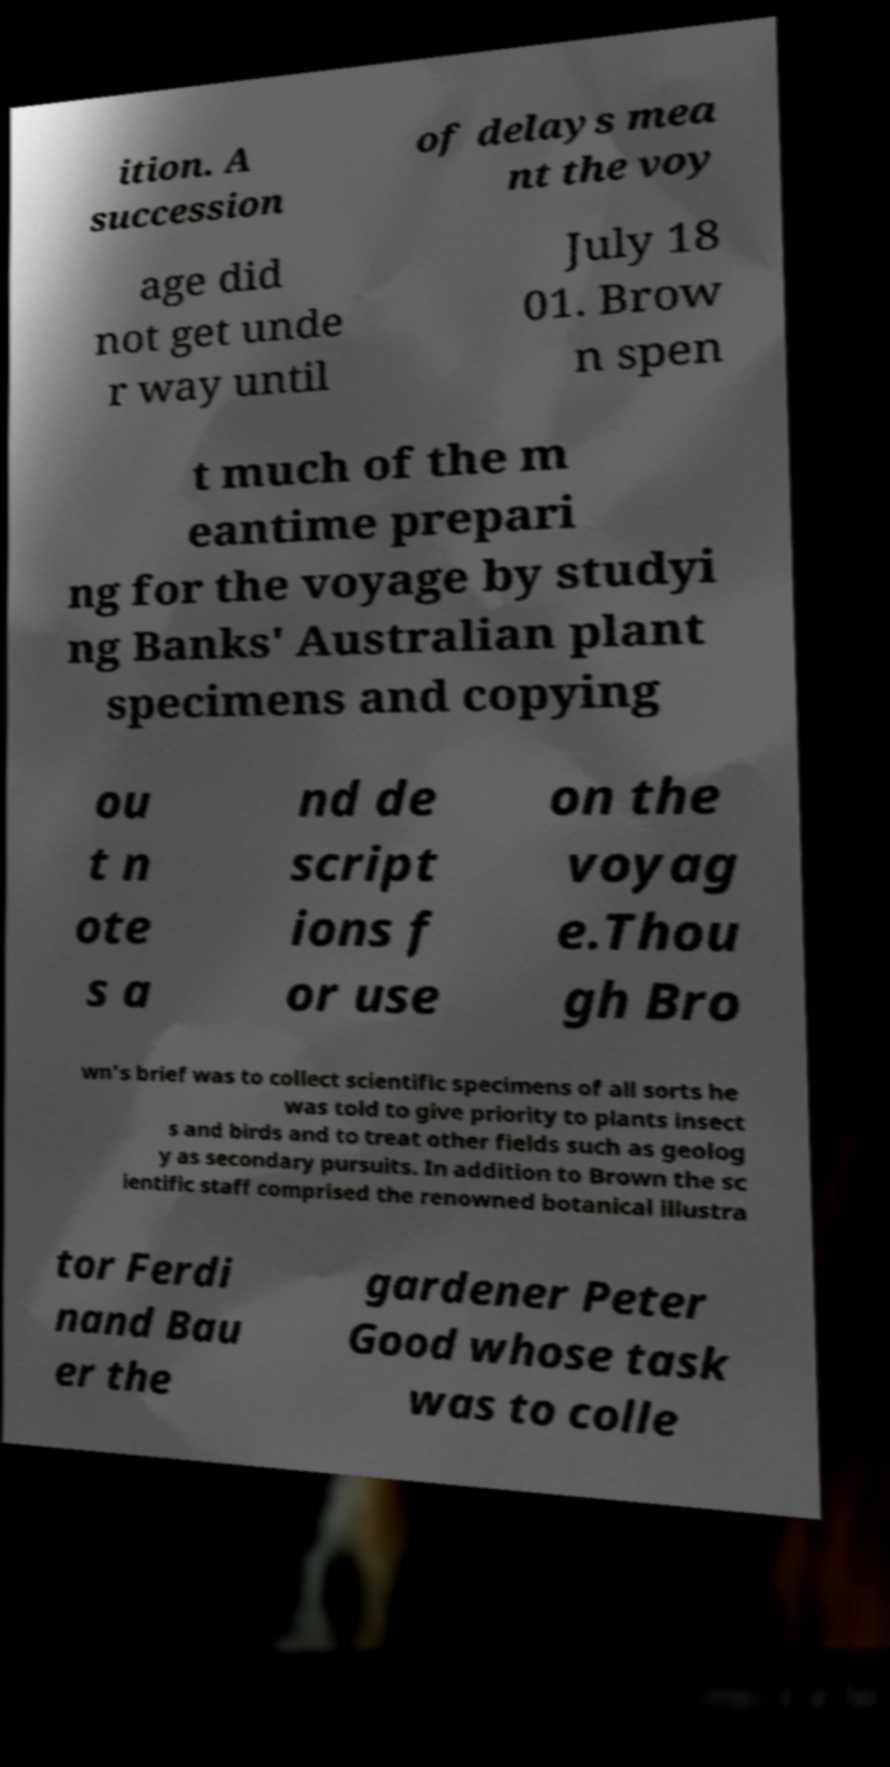Could you assist in decoding the text presented in this image and type it out clearly? ition. A succession of delays mea nt the voy age did not get unde r way until July 18 01. Brow n spen t much of the m eantime prepari ng for the voyage by studyi ng Banks' Australian plant specimens and copying ou t n ote s a nd de script ions f or use on the voyag e.Thou gh Bro wn's brief was to collect scientific specimens of all sorts he was told to give priority to plants insect s and birds and to treat other fields such as geolog y as secondary pursuits. In addition to Brown the sc ientific staff comprised the renowned botanical illustra tor Ferdi nand Bau er the gardener Peter Good whose task was to colle 